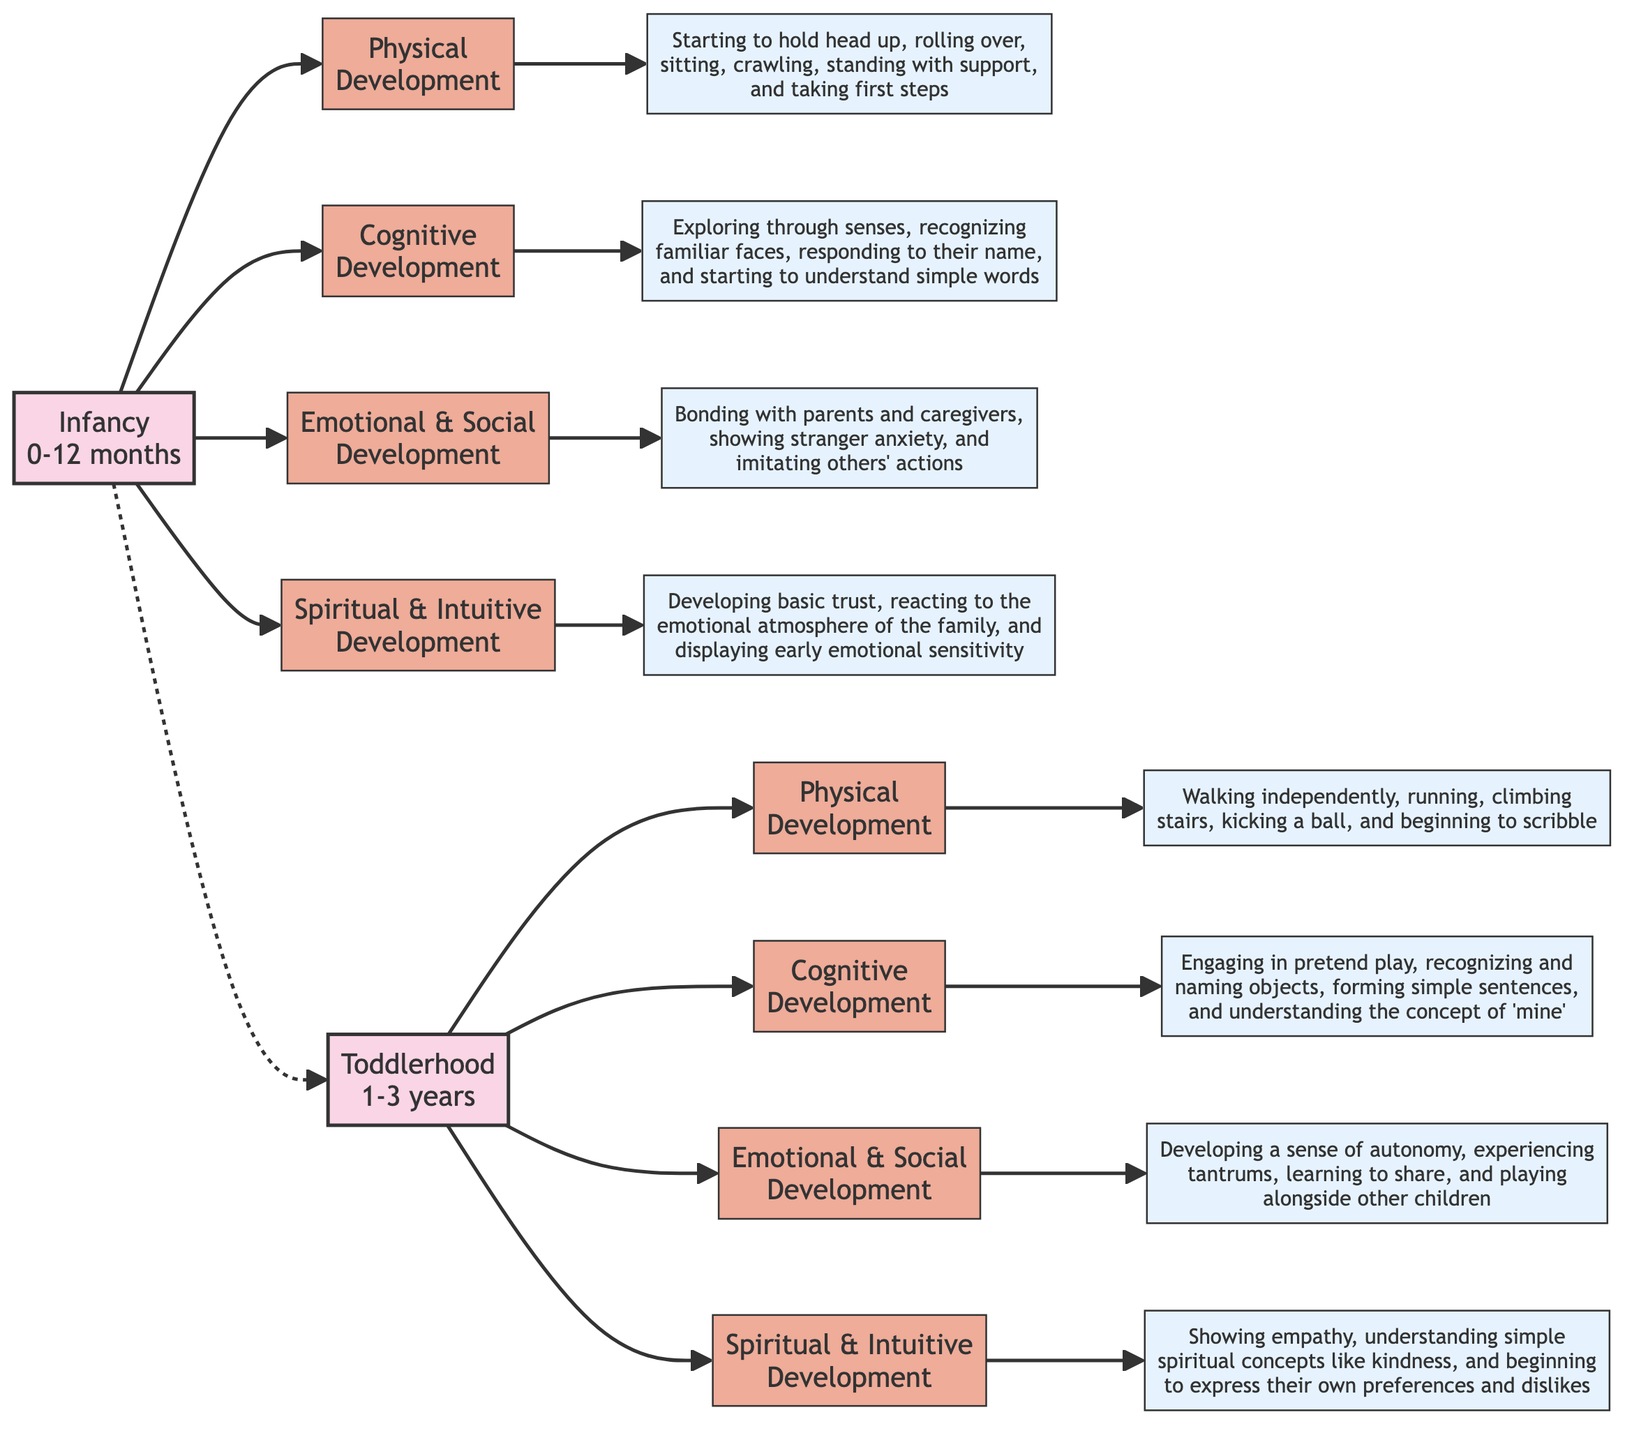What is the age range for Infancy? The diagram explicitly states the age range for the Infancy stage as "0-12 months."
Answer: 0-12 months How many milestones are there in Toddlerhood? By counting the different milestone categories listed under Toddlerhood, we see there are four: Physical Development, Cognitive Development, Emotional and Social Development, and Spiritual and Intuitive Development.
Answer: 4 What milestone comes after Emotional and Social Development in Infancy? The flowchart shows that Spiritual and Intuitive Development follows Emotional and Social Development under the Infancy stage.
Answer: Spiritual and Intuitive Development How does Physical Development in Toddlerhood differ from Infancy? Physical Development in Toddlerhood includes walking independently, running, and climbing stairs, while in Infancy, it focuses on holding head up, rolling over, and crawling. This indicates a progression in gross motor skills.
Answer: More advanced motor skills Which stage exhibits a milestone related to showing empathy? The diagram indicates that showing empathy is a part of the Spiritual and Intuitive Development milestone in the Toddlerhood stage.
Answer: Toddlerhood What is the relationship between Infancy and Toddlerhood in the diagram? The diagram shows a dashed arrow from Infancy to Toddlerhood, indicating a progression from one stage to the next, emphasizing the developmental timeline of child growth.
Answer: Progression What is a key milestone in the Emotional and Social Development category during Infancy? The Emotional and Social Development milestone during Infancy includes bonding with parents and caregivers, as stated in the description provided in the flowchart.
Answer: Bonding How many total stages of child development are displayed in the diagram? The diagram includes two distinct stages of child development: Infancy and Toddlerhood. By counting them, we determine the total.
Answer: 2 